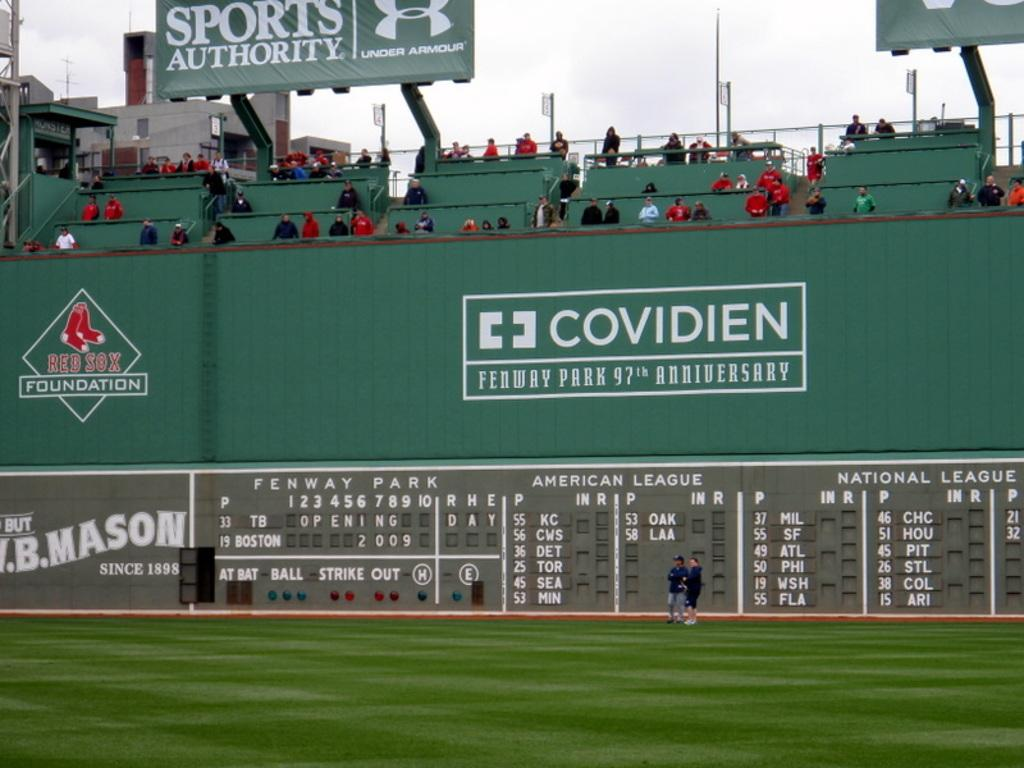<image>
Give a short and clear explanation of the subsequent image. An ad for Covidien is in a baseball park. 